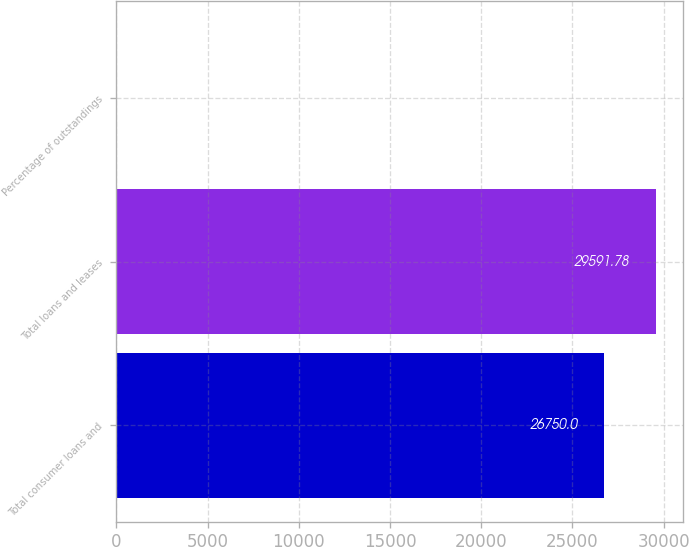<chart> <loc_0><loc_0><loc_500><loc_500><bar_chart><fcel>Total consumer loans and<fcel>Total loans and leases<fcel>Percentage of outstandings<nl><fcel>26750<fcel>29591.8<fcel>3.22<nl></chart> 